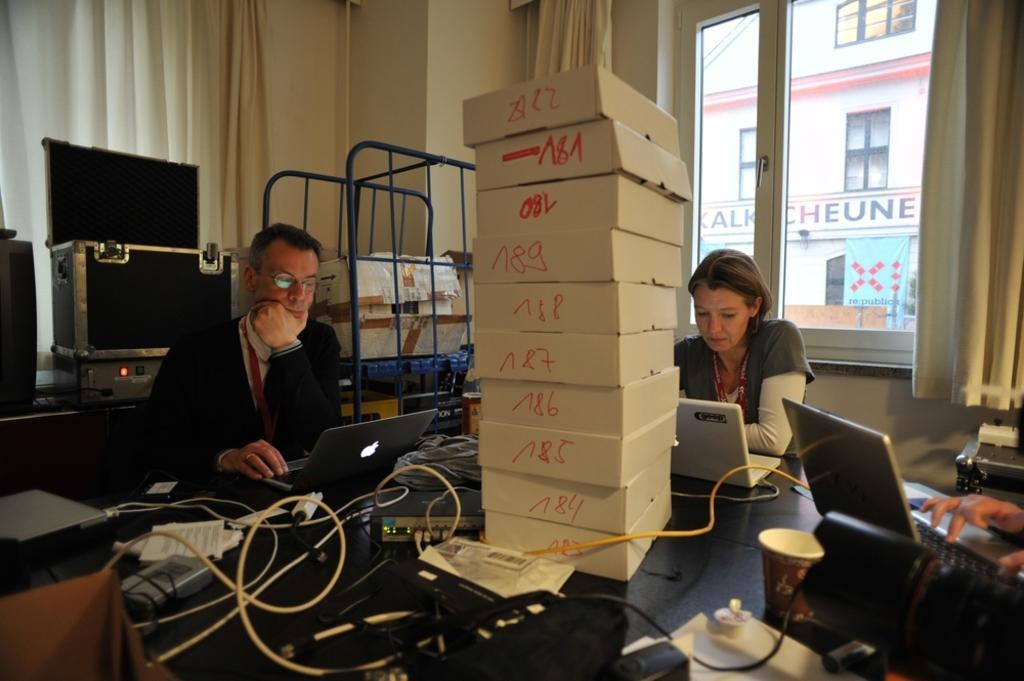How would you summarize this image in a sentence or two? In this picture there is a man wearing a black color sweater, working on the laptop. Beside there is a woman wearing a grey color t-shirt is also working on a white laptop. On the front table there is a white color boxes, some cables and extensions box. Behind there is a black and silver suitcase and metal pipe trolley. In the background there is a yellow color wall with the curtain and a glass window. 